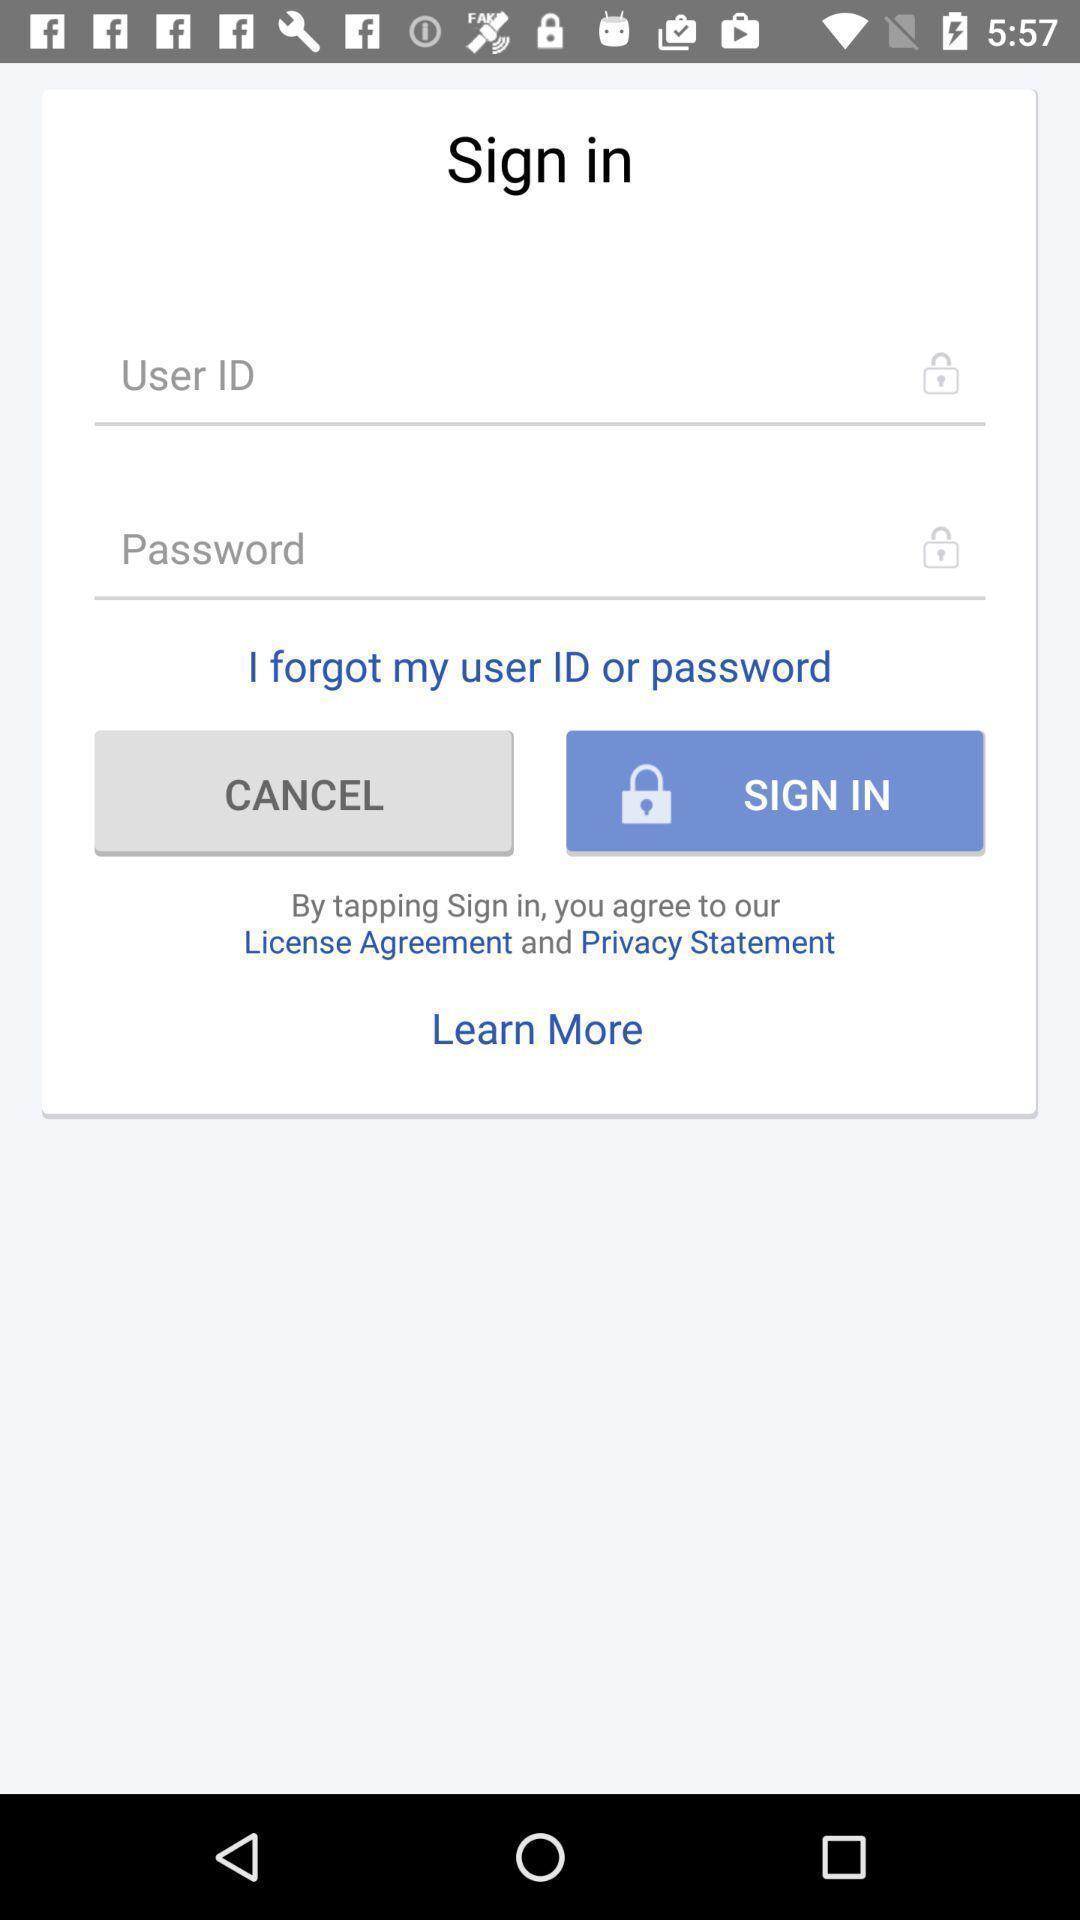Describe this image in words. Sign in page. 